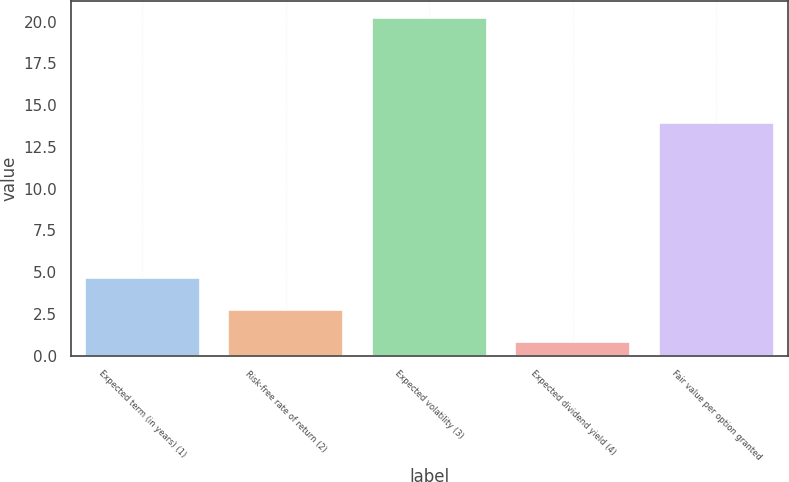<chart> <loc_0><loc_0><loc_500><loc_500><bar_chart><fcel>Expected term (in years) (1)<fcel>Risk-free rate of return (2)<fcel>Expected volatility (3)<fcel>Expected dividend yield (4)<fcel>Fair value per option granted<nl><fcel>4.68<fcel>2.74<fcel>20.2<fcel>0.8<fcel>13.9<nl></chart> 